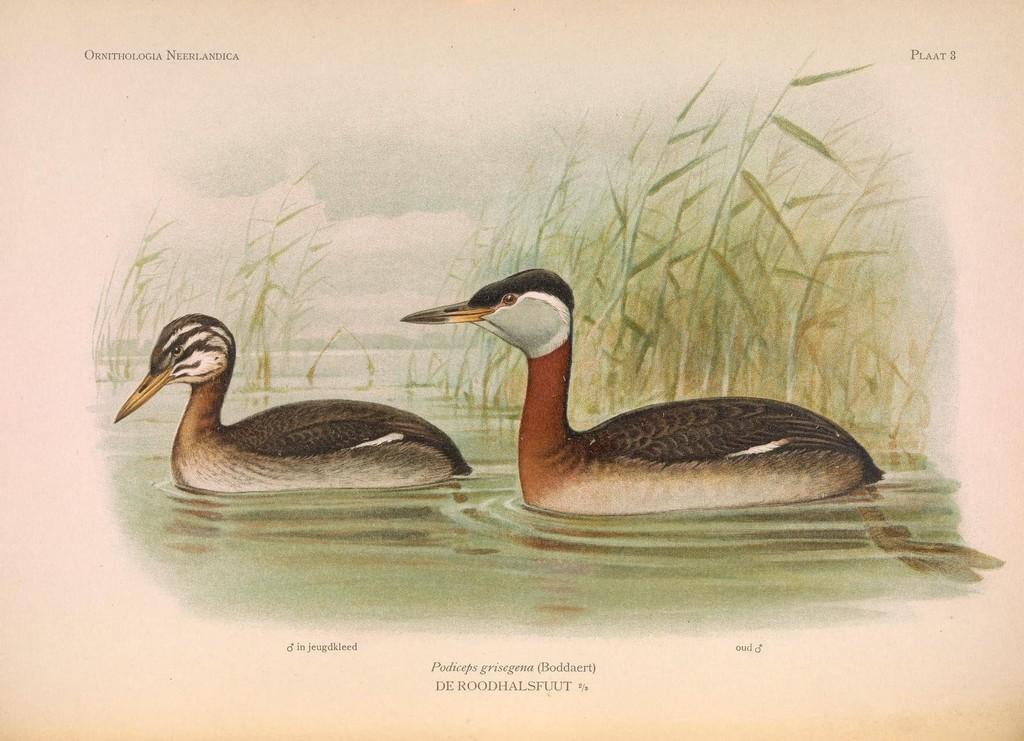What type of artwork is depicted in the image? The image is a drawing. How many ducks are present in the drawing? There are two ducks in the drawing. Where are the ducks located in the drawing? The ducks are in water. What can be seen in the background of the drawing? There is grass in the background of the drawing. What type of pest can be seen sitting on the throne in the image? There is no pest or throne present in the image; it features a drawing of two ducks in water with grass in the background. 